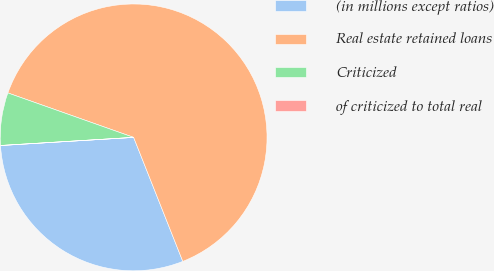Convert chart to OTSL. <chart><loc_0><loc_0><loc_500><loc_500><pie_chart><fcel>(in millions except ratios)<fcel>Real estate retained loans<fcel>Criticized<fcel>of criticized to total real<nl><fcel>30.03%<fcel>63.58%<fcel>6.37%<fcel>0.01%<nl></chart> 